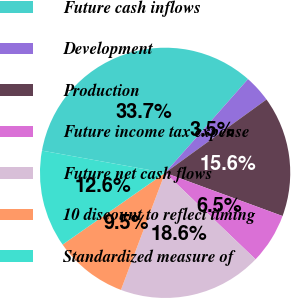Convert chart to OTSL. <chart><loc_0><loc_0><loc_500><loc_500><pie_chart><fcel>Future cash inflows<fcel>Development<fcel>Production<fcel>Future income tax expense<fcel>Future net cash flows<fcel>10 discount to reflect timing<fcel>Standardized measure of<nl><fcel>33.69%<fcel>3.51%<fcel>15.58%<fcel>6.53%<fcel>18.6%<fcel>9.54%<fcel>12.56%<nl></chart> 